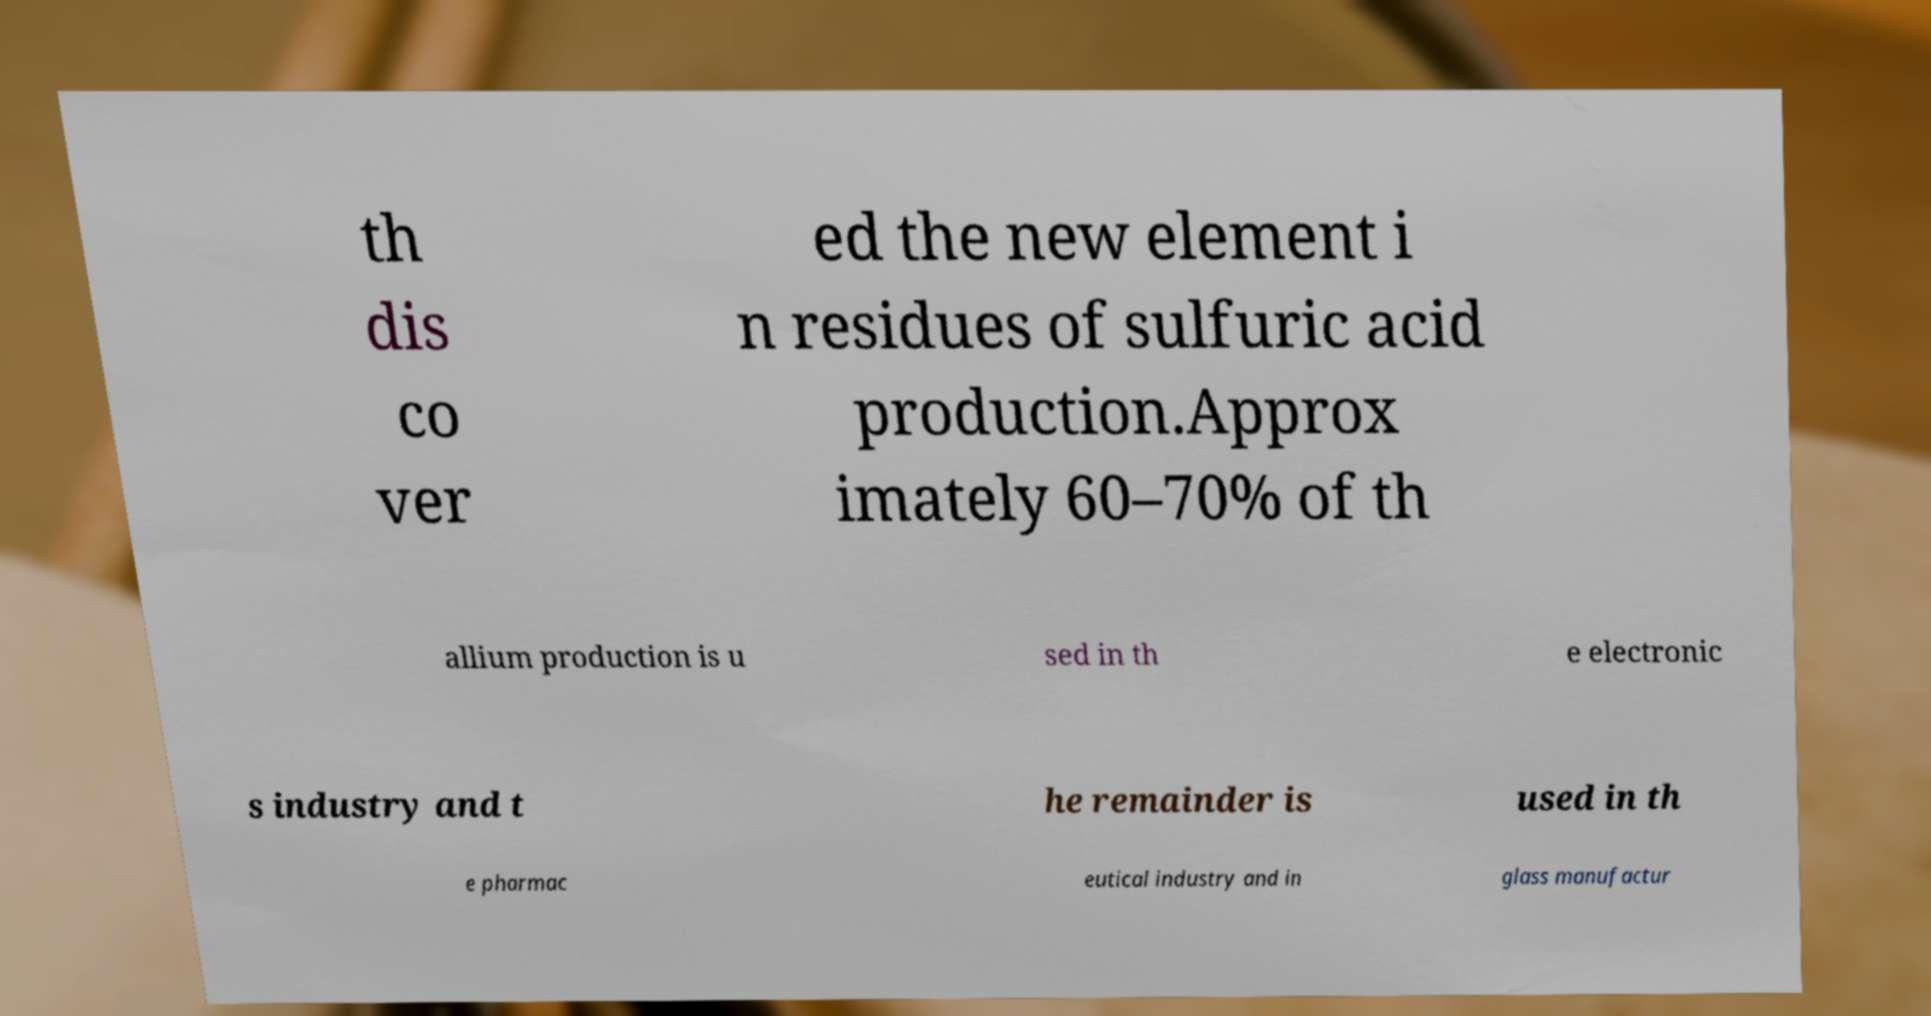Please read and relay the text visible in this image. What does it say? th dis co ver ed the new element i n residues of sulfuric acid production.Approx imately 60–70% of th allium production is u sed in th e electronic s industry and t he remainder is used in th e pharmac eutical industry and in glass manufactur 